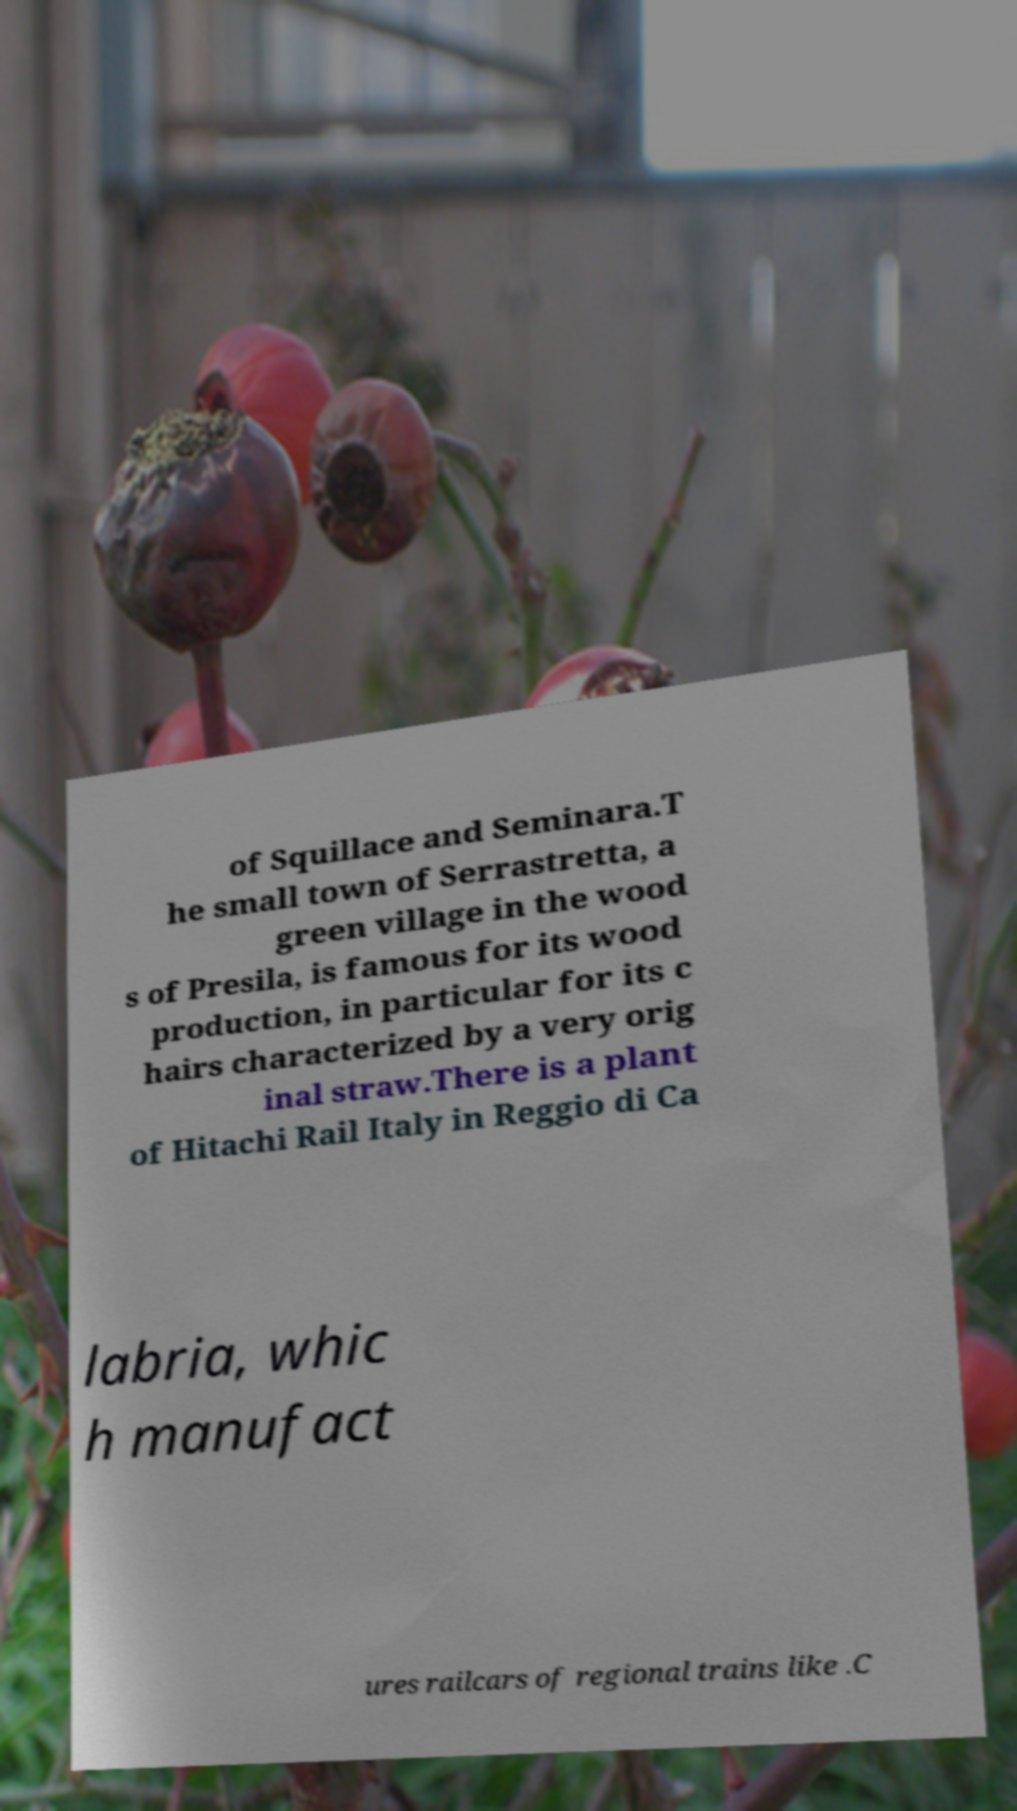Could you assist in decoding the text presented in this image and type it out clearly? of Squillace and Seminara.T he small town of Serrastretta, a green village in the wood s of Presila, is famous for its wood production, in particular for its c hairs characterized by a very orig inal straw.There is a plant of Hitachi Rail Italy in Reggio di Ca labria, whic h manufact ures railcars of regional trains like .C 